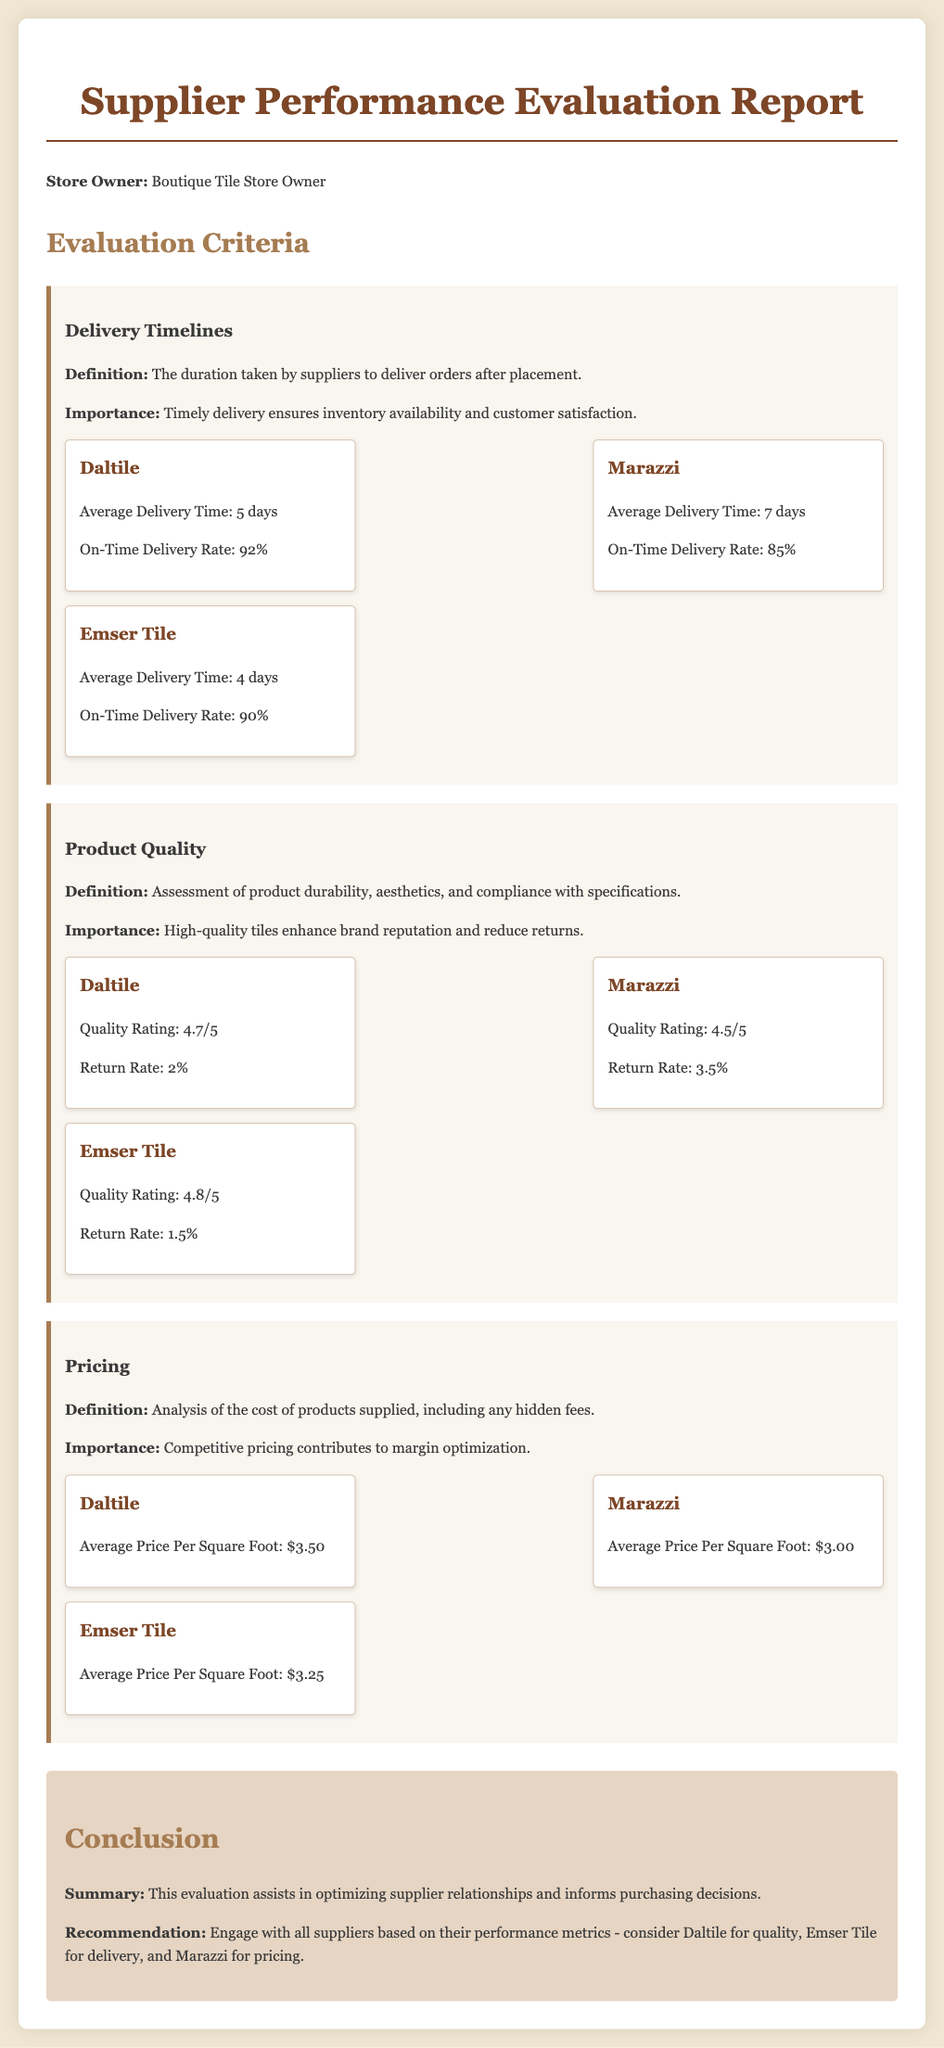what is the average delivery time for Daltile? The average delivery time for Daltile is listed under the Delivery Timelines section.
Answer: 5 days what is the quality rating of Emser Tile? The quality rating for Emser Tile can be found in the Product Quality section.
Answer: 4.8/5 which supplier has the highest return rate? The return rate for each supplier is mentioned in the Product Quality section, comparing them to identify the highest.
Answer: Marazzi what is the on-time delivery rate for Marazzi? The on-time delivery rate for Marazzi is noted in the Delivery Timelines section.
Answer: 85% what is the average price per square foot for Daltile? The average price per square foot for Daltile is provided in the Pricing section.
Answer: $3.50 which supplier is recommended for delivery? The conclusion section summarizes the recommendations based on performance metrics.
Answer: Emser Tile how many days is the average delivery time for Emser Tile? The average delivery time for Emser Tile is indicated in the Delivery Timelines section.
Answer: 4 days what is the return rate for Daltile? The return rate for Daltile is mentioned in the Product Quality section.
Answer: 2% 